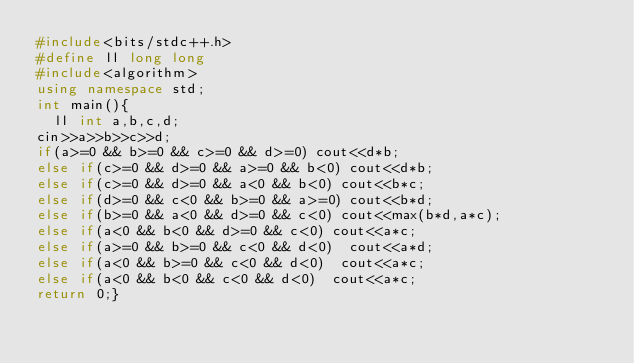Convert code to text. <code><loc_0><loc_0><loc_500><loc_500><_C++_>#include<bits/stdc++.h>
#define ll long long
#include<algorithm>
using namespace std;
int main(){
	ll int a,b,c,d;
cin>>a>>b>>c>>d;
if(a>=0 && b>=0 && c>=0 && d>=0) cout<<d*b;
else if(c>=0 && d>=0 && a>=0 && b<0) cout<<d*b;
else if(c>=0 && d>=0 && a<0 && b<0) cout<<b*c;
else if(d>=0 && c<0 && b>=0 && a>=0) cout<<b*d;
else if(b>=0 && a<0 && d>=0 && c<0) cout<<max(b*d,a*c);	
else if(a<0 && b<0 && d>=0 && c<0) cout<<a*c;
else if(a>=0 && b>=0 && c<0 && d<0)  cout<<a*d;
else if(a<0 && b>=0 && c<0 && d<0)  cout<<a*c;
else if(a<0 && b<0 && c<0 && d<0)  cout<<a*c;
return 0;}</code> 